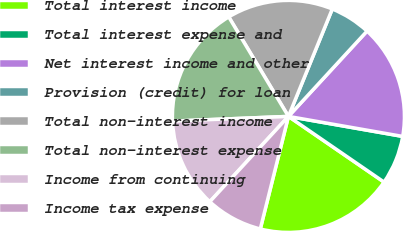Convert chart to OTSL. <chart><loc_0><loc_0><loc_500><loc_500><pie_chart><fcel>Total interest income<fcel>Total interest expense and<fcel>Net interest income and other<fcel>Provision (credit) for loan<fcel>Total non-interest income<fcel>Total non-interest expense<fcel>Income from continuing<fcel>Income tax expense<nl><fcel>19.32%<fcel>6.82%<fcel>15.91%<fcel>5.68%<fcel>14.77%<fcel>17.05%<fcel>12.5%<fcel>7.95%<nl></chart> 